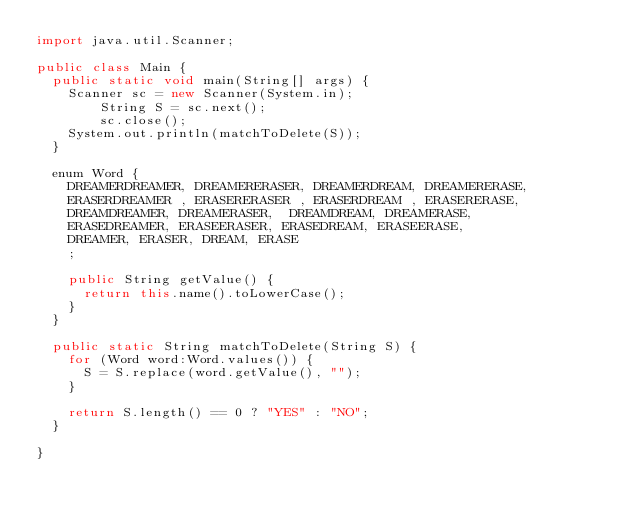<code> <loc_0><loc_0><loc_500><loc_500><_Java_>import java.util.Scanner;

public class Main {
	public static void main(String[] args) {
		Scanner sc = new Scanner(System.in);
        String S = sc.next();
        sc.close();
		System.out.println(matchToDelete(S));
	}

	enum Word {
		DREAMERDREAMER, DREAMERERASER, DREAMERDREAM, DREAMERERASE,
		ERASERDREAMER , ERASERERASER , ERASERDREAM , ERASERERASE,
		DREAMDREAMER, DREAMERASER,  DREAMDREAM, DREAMERASE,
		ERASEDREAMER, ERASEERASER, ERASEDREAM, ERASEERASE,
		DREAMER, ERASER, DREAM, ERASE
		;

		public String getValue() {
			return this.name().toLowerCase();
		}
	}

	public static String matchToDelete(String S) {
		for (Word word:Word.values()) {
			S = S.replace(word.getValue(), "");
		}

		return S.length() == 0 ? "YES" : "NO";
	}

}
</code> 